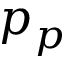<formula> <loc_0><loc_0><loc_500><loc_500>p _ { p }</formula> 